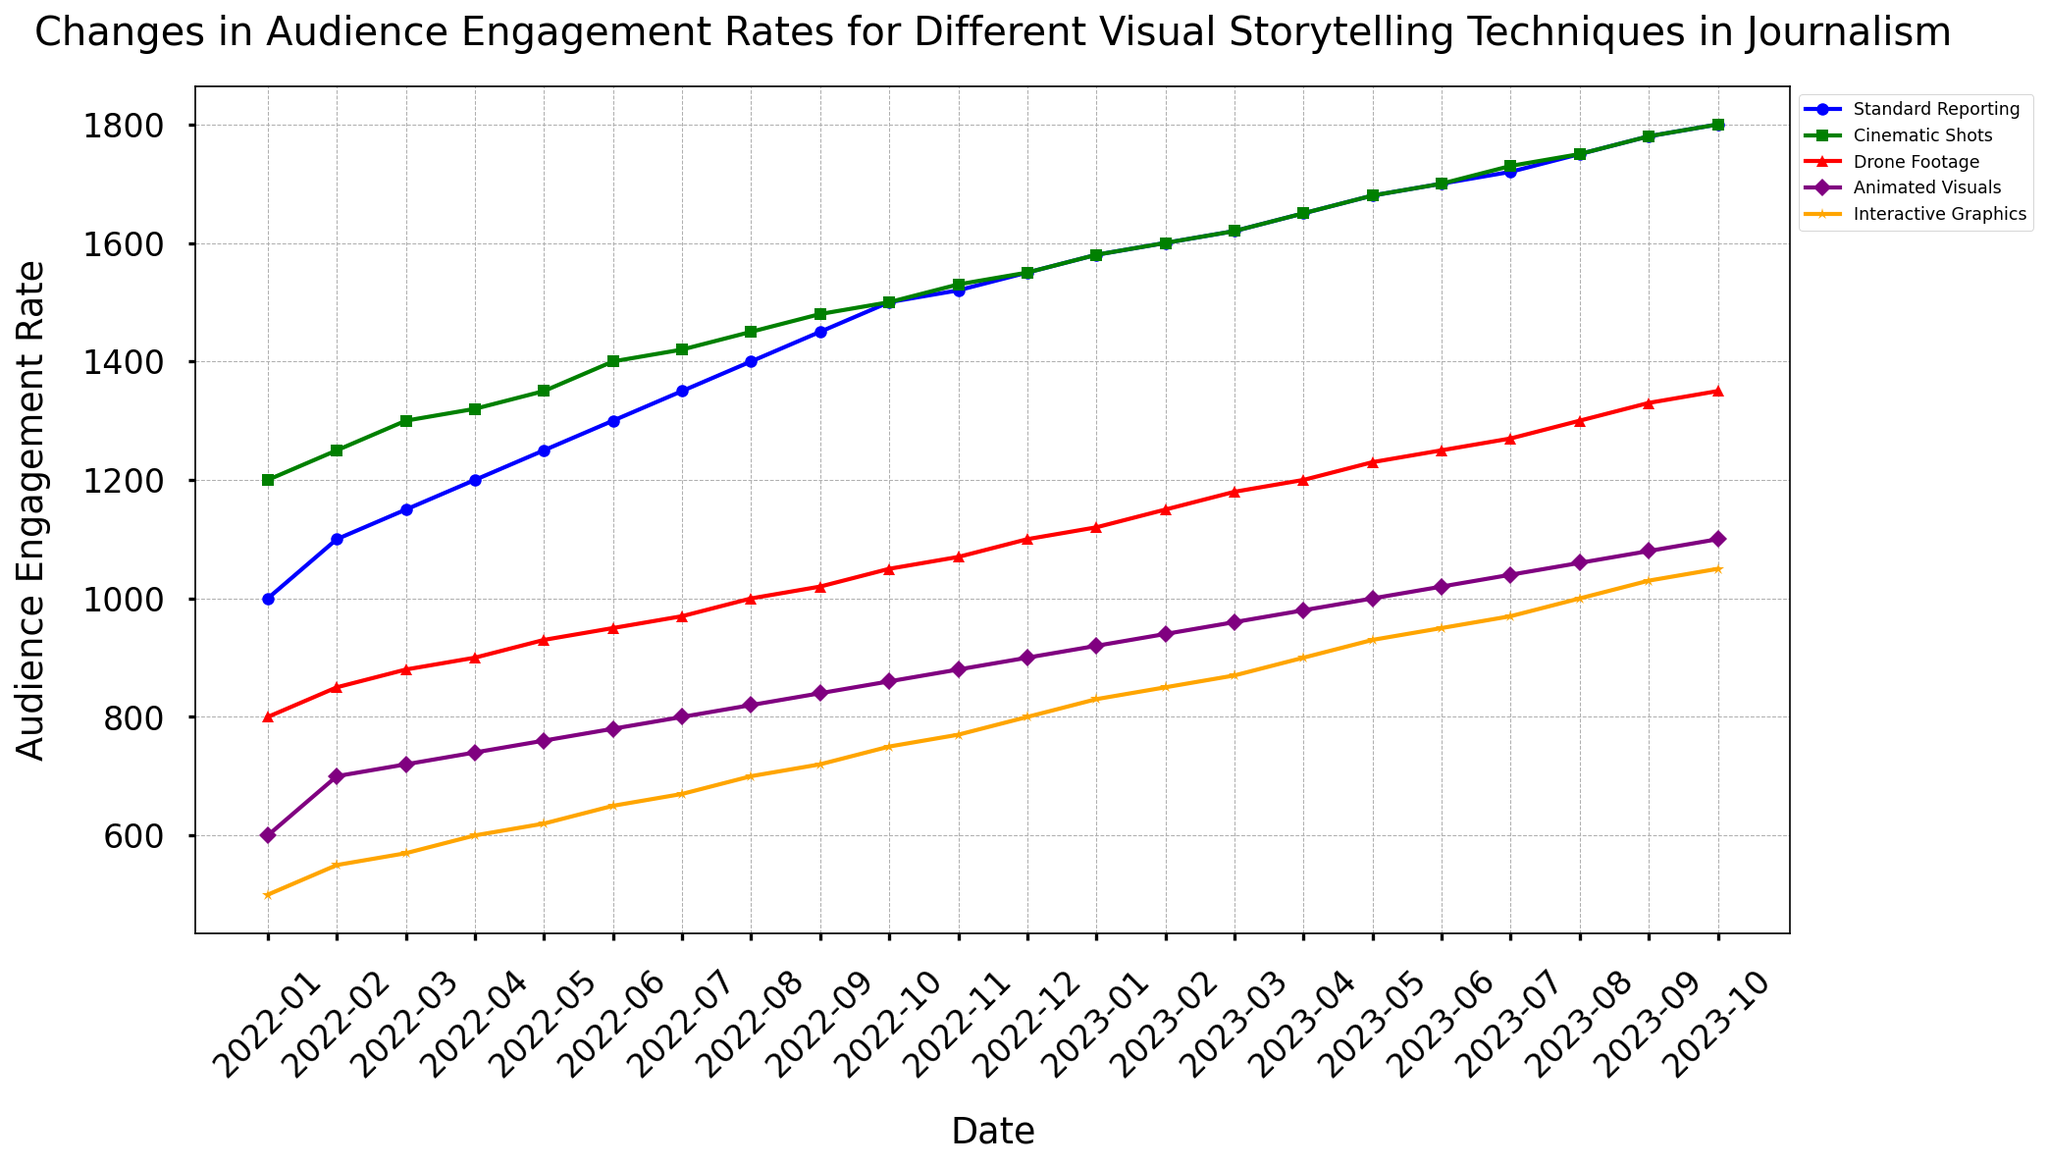Which visual storytelling technique saw the highest audience engagement rate in February 2023? The audience engagement rates for February 2023 can be seen from the data points on the line chart. The highest among standard reporting, cinematic shots, drone footage, animated visuals, and interactive graphics needs to be identified. From the chart, it is evident that 'Cinematic Shots' have the highest value.
Answer: Cinematic Shots How many months did the engagement rate for standard reporting exceed 1500? To answer this, count the number of points on the standard reporting line that are above the 1500 mark. From the chart, the months exceeding 1500 start from November 2022 and continue through October 2023.
Answer: 12 months Between which two months did drone footage experience the greatest increase in audience engagement rate? Check the line for drone footage and identify the months between which the line shows the greatest vertical increase. This appears between August 2023 to September 2023, where the audience engagement rate jumps significantly.
Answer: August 2023 and September 2023 What was the engagement rate for animated visuals in January 2023? Locate the data point on the line corresponding to animated visuals for January 2023. From the chart, this value is visibly marked.
Answer: 920 Which visual storytelling technique had the least growth in engagement rates over the entire period? Calculate the overall increase for each visual storytelling technique from January 2022 to October 2023. Identify the one with the smallest increase. Interactive graphics started at 500 and ended at 1050, thus having the least growth of 550.
Answer: Interactive Graphics By how much did the engagement rate for cinematic shots increase from January 2022 to October 2023? Note the values for cinematic shots specifically for January 2022 and October 2023. The initial value is 1200 and the final value is 1800; hence the increase is calculated as 1800 - 1200.
Answer: 600 What is the average increase in engagement rate per month for interactive graphics from January 2022 to October 2023? Calculate the total increase and divide by the number of months. Starting with 500 and ending with 1050, the total increase is 550 across 22 months (from January 2022 to October 2023). The average monthly increase is 550 / 22.
Answer: 25 Which month did standard reporting and cinematic shots first have equal engagement rates? Identify the point where the lines for standard reporting and cinematic shots intersect for the first time. Both lines appear to converge around February 2023.
Answer: February 2023 Between May 2022 and May 2023, which technique had the highest overall increase in engagement rates? Determine the engagement rates for all techniques in May 2022 and May 2023 and calculate the difference. Compare these differences to find the highest. Cinematic shots increased from 1350 to 1680, hence the highest increase.
Answer: Cinematic Shots 